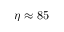Convert formula to latex. <formula><loc_0><loc_0><loc_500><loc_500>\eta \approx 8 5</formula> 